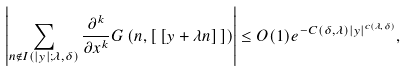Convert formula to latex. <formula><loc_0><loc_0><loc_500><loc_500>\left | \sum _ { n \notin I ( | y | ; \lambda , \delta ) } \frac { \partial ^ { k } } { \partial x ^ { k } } G \left ( n , [ \, [ y + \lambda n ] \, ] \right ) \right | \leq O ( 1 ) e ^ { - C ( \delta , \lambda ) | y | ^ { c ( \lambda , \delta ) } } ,</formula> 